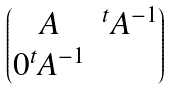Convert formula to latex. <formula><loc_0><loc_0><loc_500><loc_500>\begin{pmatrix} A & ^ { t } A ^ { - 1 } \\ 0 ^ { t } A ^ { - 1 } \end{pmatrix}</formula> 